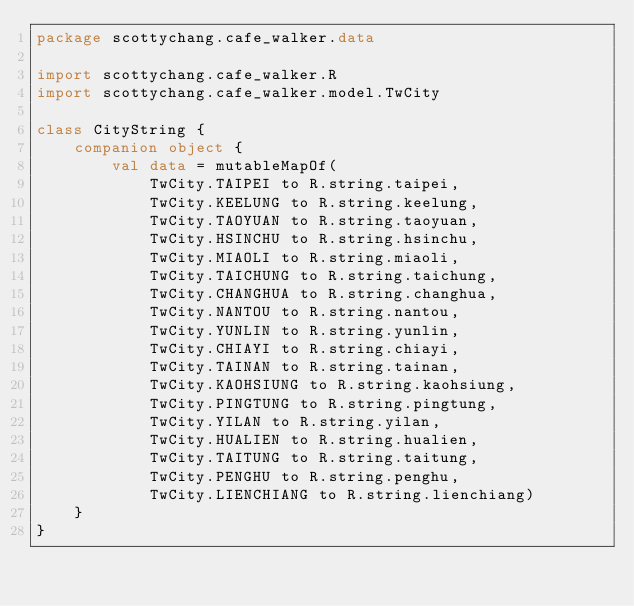<code> <loc_0><loc_0><loc_500><loc_500><_Kotlin_>package scottychang.cafe_walker.data

import scottychang.cafe_walker.R
import scottychang.cafe_walker.model.TwCity

class CityString {
    companion object {
        val data = mutableMapOf(
            TwCity.TAIPEI to R.string.taipei,
            TwCity.KEELUNG to R.string.keelung,
            TwCity.TAOYUAN to R.string.taoyuan,
            TwCity.HSINCHU to R.string.hsinchu,
            TwCity.MIAOLI to R.string.miaoli,
            TwCity.TAICHUNG to R.string.taichung,
            TwCity.CHANGHUA to R.string.changhua,
            TwCity.NANTOU to R.string.nantou,
            TwCity.YUNLIN to R.string.yunlin,
            TwCity.CHIAYI to R.string.chiayi,
            TwCity.TAINAN to R.string.tainan,
            TwCity.KAOHSIUNG to R.string.kaohsiung,
            TwCity.PINGTUNG to R.string.pingtung,
            TwCity.YILAN to R.string.yilan,
            TwCity.HUALIEN to R.string.hualien,
            TwCity.TAITUNG to R.string.taitung,
            TwCity.PENGHU to R.string.penghu,
            TwCity.LIENCHIANG to R.string.lienchiang)
    }
}</code> 